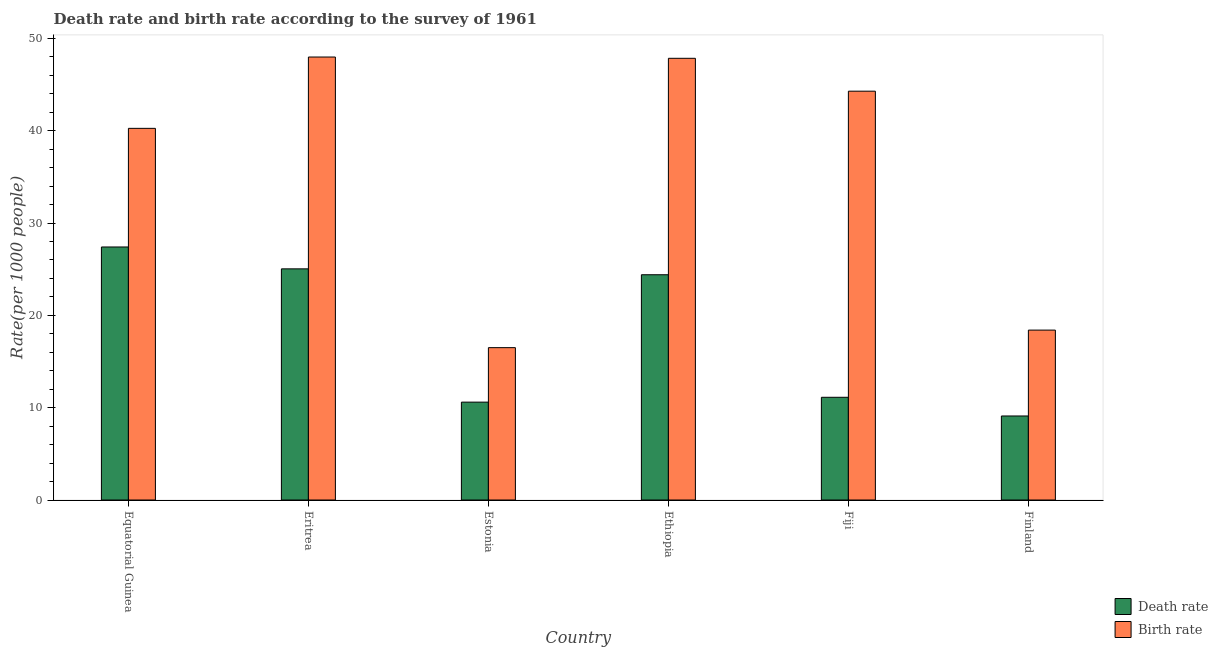Are the number of bars per tick equal to the number of legend labels?
Ensure brevity in your answer.  Yes. Are the number of bars on each tick of the X-axis equal?
Offer a very short reply. Yes. How many bars are there on the 2nd tick from the left?
Ensure brevity in your answer.  2. What is the label of the 5th group of bars from the left?
Provide a short and direct response. Fiji. What is the birth rate in Fiji?
Your answer should be compact. 44.28. Across all countries, what is the maximum birth rate?
Offer a terse response. 47.98. Across all countries, what is the minimum birth rate?
Give a very brief answer. 16.5. In which country was the birth rate maximum?
Ensure brevity in your answer.  Eritrea. What is the total birth rate in the graph?
Your response must be concise. 215.24. What is the difference between the birth rate in Eritrea and that in Ethiopia?
Make the answer very short. 0.14. What is the difference between the birth rate in Estonia and the death rate in Equatorial Guinea?
Your answer should be very brief. -10.9. What is the average birth rate per country?
Keep it short and to the point. 35.87. What is the difference between the death rate and birth rate in Eritrea?
Your answer should be compact. -22.94. In how many countries, is the birth rate greater than 40 ?
Your answer should be very brief. 4. What is the ratio of the death rate in Eritrea to that in Ethiopia?
Keep it short and to the point. 1.03. Is the birth rate in Ethiopia less than that in Fiji?
Ensure brevity in your answer.  No. What is the difference between the highest and the second highest death rate?
Your response must be concise. 2.37. What is the difference between the highest and the lowest death rate?
Your answer should be very brief. 18.3. In how many countries, is the birth rate greater than the average birth rate taken over all countries?
Ensure brevity in your answer.  4. What does the 2nd bar from the left in Eritrea represents?
Your response must be concise. Birth rate. What does the 1st bar from the right in Equatorial Guinea represents?
Your response must be concise. Birth rate. Are all the bars in the graph horizontal?
Give a very brief answer. No. How many countries are there in the graph?
Provide a succinct answer. 6. Does the graph contain any zero values?
Your answer should be compact. No. How many legend labels are there?
Ensure brevity in your answer.  2. What is the title of the graph?
Your answer should be very brief. Death rate and birth rate according to the survey of 1961. Does "Female" appear as one of the legend labels in the graph?
Offer a very short reply. No. What is the label or title of the X-axis?
Ensure brevity in your answer.  Country. What is the label or title of the Y-axis?
Your answer should be very brief. Rate(per 1000 people). What is the Rate(per 1000 people) of Death rate in Equatorial Guinea?
Provide a short and direct response. 27.4. What is the Rate(per 1000 people) of Birth rate in Equatorial Guinea?
Provide a succinct answer. 40.25. What is the Rate(per 1000 people) of Death rate in Eritrea?
Ensure brevity in your answer.  25.03. What is the Rate(per 1000 people) in Birth rate in Eritrea?
Your answer should be very brief. 47.98. What is the Rate(per 1000 people) of Death rate in Ethiopia?
Ensure brevity in your answer.  24.4. What is the Rate(per 1000 people) in Birth rate in Ethiopia?
Your answer should be compact. 47.84. What is the Rate(per 1000 people) of Death rate in Fiji?
Your answer should be very brief. 11.12. What is the Rate(per 1000 people) of Birth rate in Fiji?
Make the answer very short. 44.28. What is the Rate(per 1000 people) in Death rate in Finland?
Ensure brevity in your answer.  9.1. What is the Rate(per 1000 people) of Birth rate in Finland?
Your answer should be very brief. 18.4. Across all countries, what is the maximum Rate(per 1000 people) in Death rate?
Ensure brevity in your answer.  27.4. Across all countries, what is the maximum Rate(per 1000 people) in Birth rate?
Offer a very short reply. 47.98. Across all countries, what is the minimum Rate(per 1000 people) of Death rate?
Give a very brief answer. 9.1. What is the total Rate(per 1000 people) in Death rate in the graph?
Offer a very short reply. 107.66. What is the total Rate(per 1000 people) of Birth rate in the graph?
Your response must be concise. 215.24. What is the difference between the Rate(per 1000 people) of Death rate in Equatorial Guinea and that in Eritrea?
Provide a short and direct response. 2.37. What is the difference between the Rate(per 1000 people) in Birth rate in Equatorial Guinea and that in Eritrea?
Give a very brief answer. -7.72. What is the difference between the Rate(per 1000 people) in Death rate in Equatorial Guinea and that in Estonia?
Your answer should be compact. 16.8. What is the difference between the Rate(per 1000 people) of Birth rate in Equatorial Guinea and that in Estonia?
Provide a short and direct response. 23.75. What is the difference between the Rate(per 1000 people) in Death rate in Equatorial Guinea and that in Ethiopia?
Your answer should be very brief. 3.01. What is the difference between the Rate(per 1000 people) of Birth rate in Equatorial Guinea and that in Ethiopia?
Give a very brief answer. -7.59. What is the difference between the Rate(per 1000 people) of Death rate in Equatorial Guinea and that in Fiji?
Your answer should be very brief. 16.28. What is the difference between the Rate(per 1000 people) of Birth rate in Equatorial Guinea and that in Fiji?
Your response must be concise. -4.03. What is the difference between the Rate(per 1000 people) in Death rate in Equatorial Guinea and that in Finland?
Your answer should be very brief. 18.3. What is the difference between the Rate(per 1000 people) of Birth rate in Equatorial Guinea and that in Finland?
Your answer should be compact. 21.85. What is the difference between the Rate(per 1000 people) of Death rate in Eritrea and that in Estonia?
Offer a terse response. 14.43. What is the difference between the Rate(per 1000 people) of Birth rate in Eritrea and that in Estonia?
Make the answer very short. 31.48. What is the difference between the Rate(per 1000 people) in Death rate in Eritrea and that in Ethiopia?
Ensure brevity in your answer.  0.64. What is the difference between the Rate(per 1000 people) in Birth rate in Eritrea and that in Ethiopia?
Your answer should be very brief. 0.14. What is the difference between the Rate(per 1000 people) of Death rate in Eritrea and that in Fiji?
Ensure brevity in your answer.  13.91. What is the difference between the Rate(per 1000 people) of Birth rate in Eritrea and that in Fiji?
Your answer should be very brief. 3.7. What is the difference between the Rate(per 1000 people) in Death rate in Eritrea and that in Finland?
Offer a very short reply. 15.93. What is the difference between the Rate(per 1000 people) in Birth rate in Eritrea and that in Finland?
Give a very brief answer. 29.58. What is the difference between the Rate(per 1000 people) of Death rate in Estonia and that in Ethiopia?
Your answer should be compact. -13.8. What is the difference between the Rate(per 1000 people) of Birth rate in Estonia and that in Ethiopia?
Your answer should be very brief. -31.34. What is the difference between the Rate(per 1000 people) of Death rate in Estonia and that in Fiji?
Offer a terse response. -0.53. What is the difference between the Rate(per 1000 people) in Birth rate in Estonia and that in Fiji?
Your answer should be very brief. -27.78. What is the difference between the Rate(per 1000 people) in Death rate in Ethiopia and that in Fiji?
Keep it short and to the point. 13.27. What is the difference between the Rate(per 1000 people) of Birth rate in Ethiopia and that in Fiji?
Make the answer very short. 3.56. What is the difference between the Rate(per 1000 people) in Death rate in Ethiopia and that in Finland?
Offer a terse response. 15.3. What is the difference between the Rate(per 1000 people) of Birth rate in Ethiopia and that in Finland?
Your answer should be very brief. 29.44. What is the difference between the Rate(per 1000 people) of Death rate in Fiji and that in Finland?
Your answer should be compact. 2.02. What is the difference between the Rate(per 1000 people) of Birth rate in Fiji and that in Finland?
Offer a terse response. 25.88. What is the difference between the Rate(per 1000 people) of Death rate in Equatorial Guinea and the Rate(per 1000 people) of Birth rate in Eritrea?
Your response must be concise. -20.57. What is the difference between the Rate(per 1000 people) of Death rate in Equatorial Guinea and the Rate(per 1000 people) of Birth rate in Estonia?
Your answer should be very brief. 10.9. What is the difference between the Rate(per 1000 people) in Death rate in Equatorial Guinea and the Rate(per 1000 people) in Birth rate in Ethiopia?
Your answer should be very brief. -20.43. What is the difference between the Rate(per 1000 people) in Death rate in Equatorial Guinea and the Rate(per 1000 people) in Birth rate in Fiji?
Offer a terse response. -16.87. What is the difference between the Rate(per 1000 people) in Death rate in Equatorial Guinea and the Rate(per 1000 people) in Birth rate in Finland?
Provide a succinct answer. 9. What is the difference between the Rate(per 1000 people) of Death rate in Eritrea and the Rate(per 1000 people) of Birth rate in Estonia?
Make the answer very short. 8.53. What is the difference between the Rate(per 1000 people) in Death rate in Eritrea and the Rate(per 1000 people) in Birth rate in Ethiopia?
Provide a short and direct response. -22.8. What is the difference between the Rate(per 1000 people) in Death rate in Eritrea and the Rate(per 1000 people) in Birth rate in Fiji?
Your response must be concise. -19.24. What is the difference between the Rate(per 1000 people) in Death rate in Eritrea and the Rate(per 1000 people) in Birth rate in Finland?
Offer a terse response. 6.63. What is the difference between the Rate(per 1000 people) of Death rate in Estonia and the Rate(per 1000 people) of Birth rate in Ethiopia?
Offer a very short reply. -37.24. What is the difference between the Rate(per 1000 people) in Death rate in Estonia and the Rate(per 1000 people) in Birth rate in Fiji?
Ensure brevity in your answer.  -33.68. What is the difference between the Rate(per 1000 people) in Death rate in Ethiopia and the Rate(per 1000 people) in Birth rate in Fiji?
Your answer should be compact. -19.88. What is the difference between the Rate(per 1000 people) of Death rate in Ethiopia and the Rate(per 1000 people) of Birth rate in Finland?
Your answer should be very brief. 6. What is the difference between the Rate(per 1000 people) of Death rate in Fiji and the Rate(per 1000 people) of Birth rate in Finland?
Offer a very short reply. -7.28. What is the average Rate(per 1000 people) in Death rate per country?
Provide a succinct answer. 17.94. What is the average Rate(per 1000 people) of Birth rate per country?
Provide a short and direct response. 35.87. What is the difference between the Rate(per 1000 people) of Death rate and Rate(per 1000 people) of Birth rate in Equatorial Guinea?
Your answer should be compact. -12.85. What is the difference between the Rate(per 1000 people) in Death rate and Rate(per 1000 people) in Birth rate in Eritrea?
Keep it short and to the point. -22.94. What is the difference between the Rate(per 1000 people) in Death rate and Rate(per 1000 people) in Birth rate in Ethiopia?
Keep it short and to the point. -23.44. What is the difference between the Rate(per 1000 people) of Death rate and Rate(per 1000 people) of Birth rate in Fiji?
Make the answer very short. -33.15. What is the ratio of the Rate(per 1000 people) of Death rate in Equatorial Guinea to that in Eritrea?
Your answer should be very brief. 1.09. What is the ratio of the Rate(per 1000 people) in Birth rate in Equatorial Guinea to that in Eritrea?
Provide a succinct answer. 0.84. What is the ratio of the Rate(per 1000 people) in Death rate in Equatorial Guinea to that in Estonia?
Give a very brief answer. 2.59. What is the ratio of the Rate(per 1000 people) in Birth rate in Equatorial Guinea to that in Estonia?
Your answer should be very brief. 2.44. What is the ratio of the Rate(per 1000 people) in Death rate in Equatorial Guinea to that in Ethiopia?
Offer a terse response. 1.12. What is the ratio of the Rate(per 1000 people) of Birth rate in Equatorial Guinea to that in Ethiopia?
Ensure brevity in your answer.  0.84. What is the ratio of the Rate(per 1000 people) in Death rate in Equatorial Guinea to that in Fiji?
Your answer should be compact. 2.46. What is the ratio of the Rate(per 1000 people) of Death rate in Equatorial Guinea to that in Finland?
Your answer should be compact. 3.01. What is the ratio of the Rate(per 1000 people) of Birth rate in Equatorial Guinea to that in Finland?
Provide a succinct answer. 2.19. What is the ratio of the Rate(per 1000 people) of Death rate in Eritrea to that in Estonia?
Keep it short and to the point. 2.36. What is the ratio of the Rate(per 1000 people) of Birth rate in Eritrea to that in Estonia?
Your answer should be compact. 2.91. What is the ratio of the Rate(per 1000 people) of Death rate in Eritrea to that in Ethiopia?
Keep it short and to the point. 1.03. What is the ratio of the Rate(per 1000 people) in Birth rate in Eritrea to that in Ethiopia?
Give a very brief answer. 1. What is the ratio of the Rate(per 1000 people) of Death rate in Eritrea to that in Fiji?
Your response must be concise. 2.25. What is the ratio of the Rate(per 1000 people) in Birth rate in Eritrea to that in Fiji?
Provide a short and direct response. 1.08. What is the ratio of the Rate(per 1000 people) of Death rate in Eritrea to that in Finland?
Offer a terse response. 2.75. What is the ratio of the Rate(per 1000 people) of Birth rate in Eritrea to that in Finland?
Your answer should be compact. 2.61. What is the ratio of the Rate(per 1000 people) of Death rate in Estonia to that in Ethiopia?
Your answer should be compact. 0.43. What is the ratio of the Rate(per 1000 people) of Birth rate in Estonia to that in Ethiopia?
Your answer should be compact. 0.34. What is the ratio of the Rate(per 1000 people) in Death rate in Estonia to that in Fiji?
Offer a very short reply. 0.95. What is the ratio of the Rate(per 1000 people) of Birth rate in Estonia to that in Fiji?
Provide a succinct answer. 0.37. What is the ratio of the Rate(per 1000 people) of Death rate in Estonia to that in Finland?
Provide a succinct answer. 1.16. What is the ratio of the Rate(per 1000 people) of Birth rate in Estonia to that in Finland?
Ensure brevity in your answer.  0.9. What is the ratio of the Rate(per 1000 people) of Death rate in Ethiopia to that in Fiji?
Keep it short and to the point. 2.19. What is the ratio of the Rate(per 1000 people) of Birth rate in Ethiopia to that in Fiji?
Make the answer very short. 1.08. What is the ratio of the Rate(per 1000 people) of Death rate in Ethiopia to that in Finland?
Offer a very short reply. 2.68. What is the ratio of the Rate(per 1000 people) in Birth rate in Ethiopia to that in Finland?
Offer a terse response. 2.6. What is the ratio of the Rate(per 1000 people) of Death rate in Fiji to that in Finland?
Your answer should be very brief. 1.22. What is the ratio of the Rate(per 1000 people) of Birth rate in Fiji to that in Finland?
Your answer should be very brief. 2.41. What is the difference between the highest and the second highest Rate(per 1000 people) in Death rate?
Your answer should be very brief. 2.37. What is the difference between the highest and the second highest Rate(per 1000 people) in Birth rate?
Provide a short and direct response. 0.14. What is the difference between the highest and the lowest Rate(per 1000 people) in Death rate?
Provide a short and direct response. 18.3. What is the difference between the highest and the lowest Rate(per 1000 people) of Birth rate?
Ensure brevity in your answer.  31.48. 